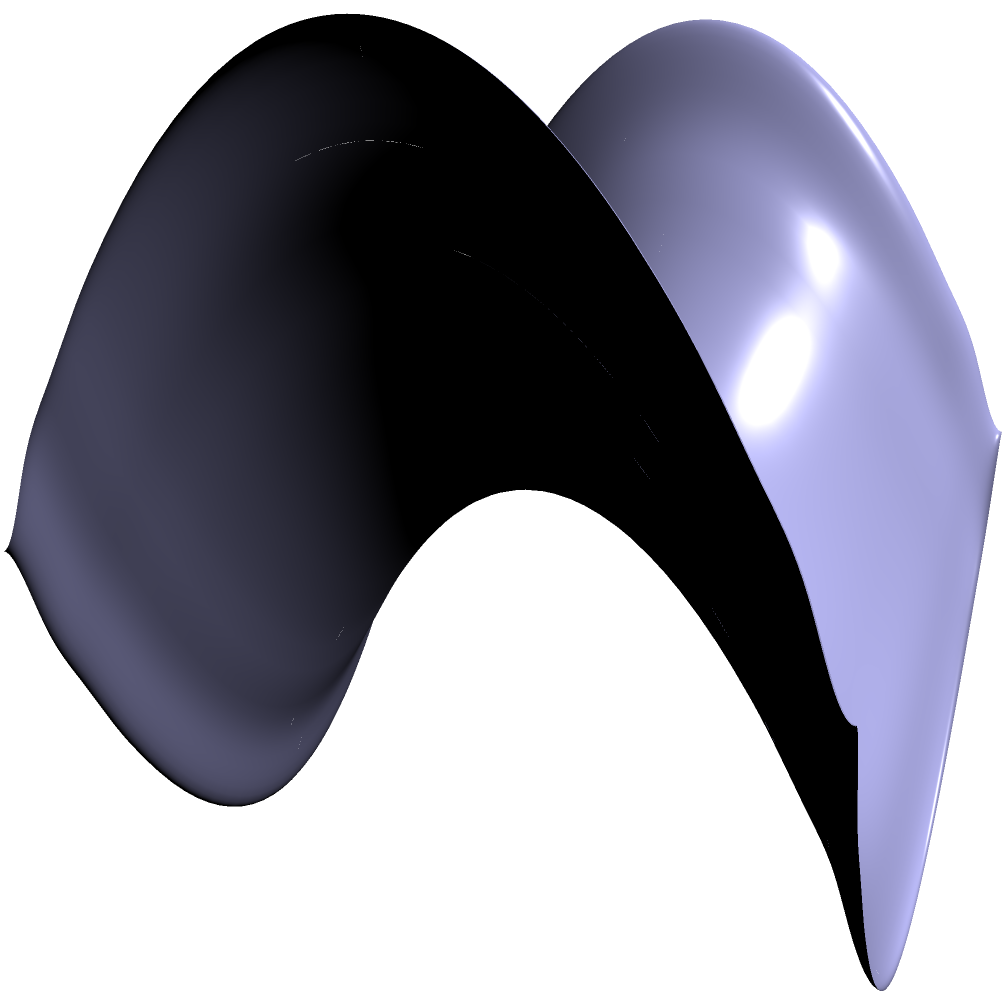As a postal carrier navigating through a non-Euclidean neighborhood, you encounter a saddle-shaped surface represented by the equation $z = x^2 - y^2$. If you were to deliver a package along the shortest path from point A $(-1.5, -1.5, 0)$ to point B $(1.5, 1.5, 0)$, which of the following best describes the path you would take?

a) A straight line between A and B
b) A curved path that follows the contour of the surface
c) A zigzag path to avoid the steepest parts of the surface
d) A path that goes through the origin $(0, 0, 0)$ To answer this question, let's consider the properties of geodesics on a saddle-shaped surface:

1. In non-Euclidean geometry, the shortest path between two points is called a geodesic.

2. On a saddle-shaped surface (hyperbolic paraboloid), geodesics are not straight lines when projected onto the xy-plane.

3. The surface $z = x^2 - y^2$ has a saddle point at the origin $(0, 0, 0)$.

4. Geodesics on this surface tend to curve towards the saddle point.

5. The shortest path between two points on opposite sides of the saddle point will pass through or near the saddle point.

6. In this case, points A $(-1.5, -1.5, 0)$ and B $(1.5, 1.5, 0)$ are on opposite sides of the saddle point.

7. Therefore, the geodesic (shortest path) between A and B will curve towards the origin and pass through it.

8. This path is represented by the red curve in the diagram, which goes through the origin $(0, 0, 0)$.

Given these considerations, the best description of the path you would take to deliver the package along the shortest route is option d: A path that goes through the origin $(0, 0, 0)$.
Answer: d 